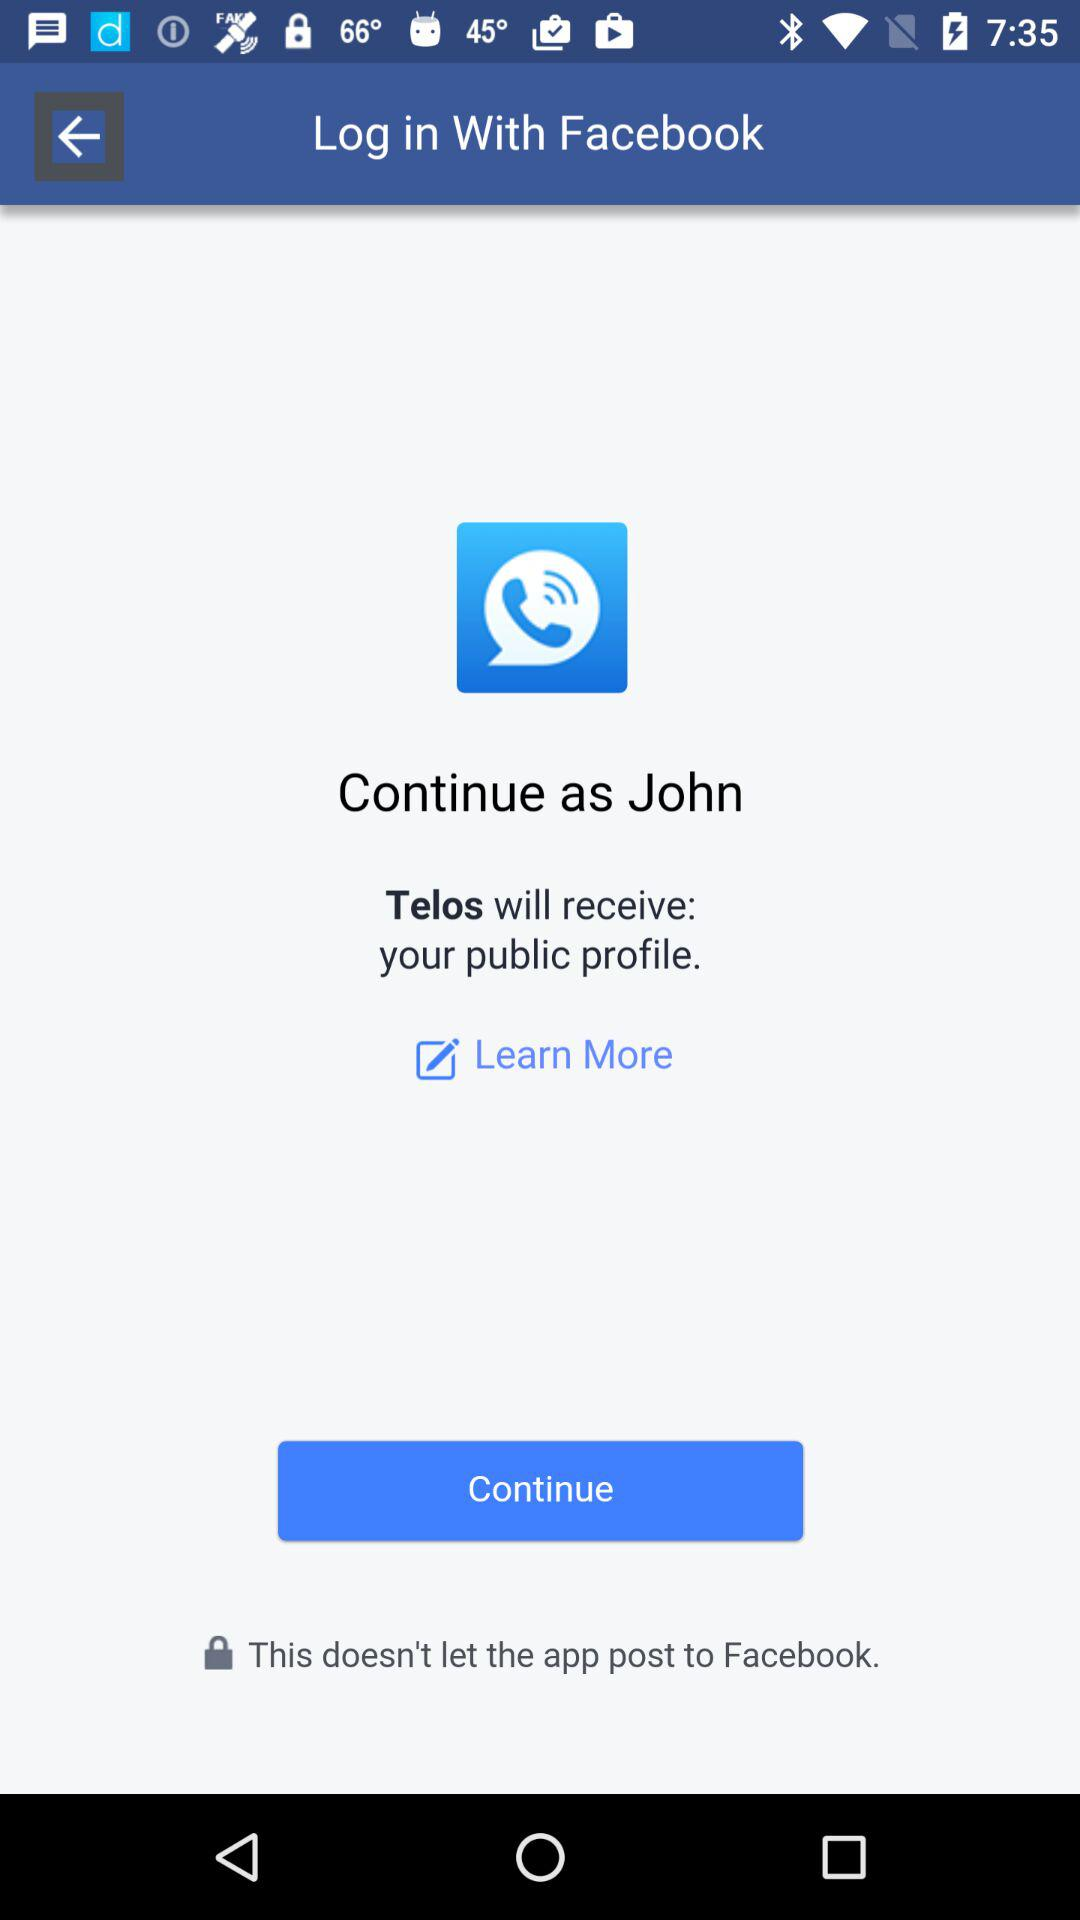Through what application is the person logging in? The person is logging in through "Facebook". 